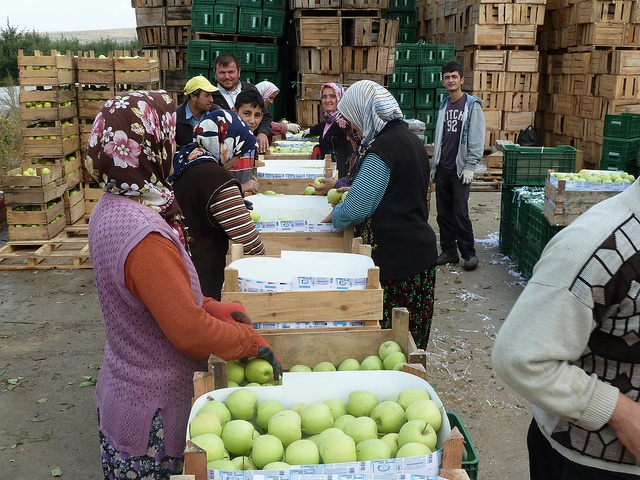Describe the objects in this image and their specific colors. I can see people in white, purple, black, maroon, and brown tones, people in white, darkgray, black, gray, and lightgray tones, apple in white, khaki, olive, and lightgray tones, people in white, black, gray, darkgray, and blue tones, and people in white, black, maroon, lightgray, and darkgray tones in this image. 